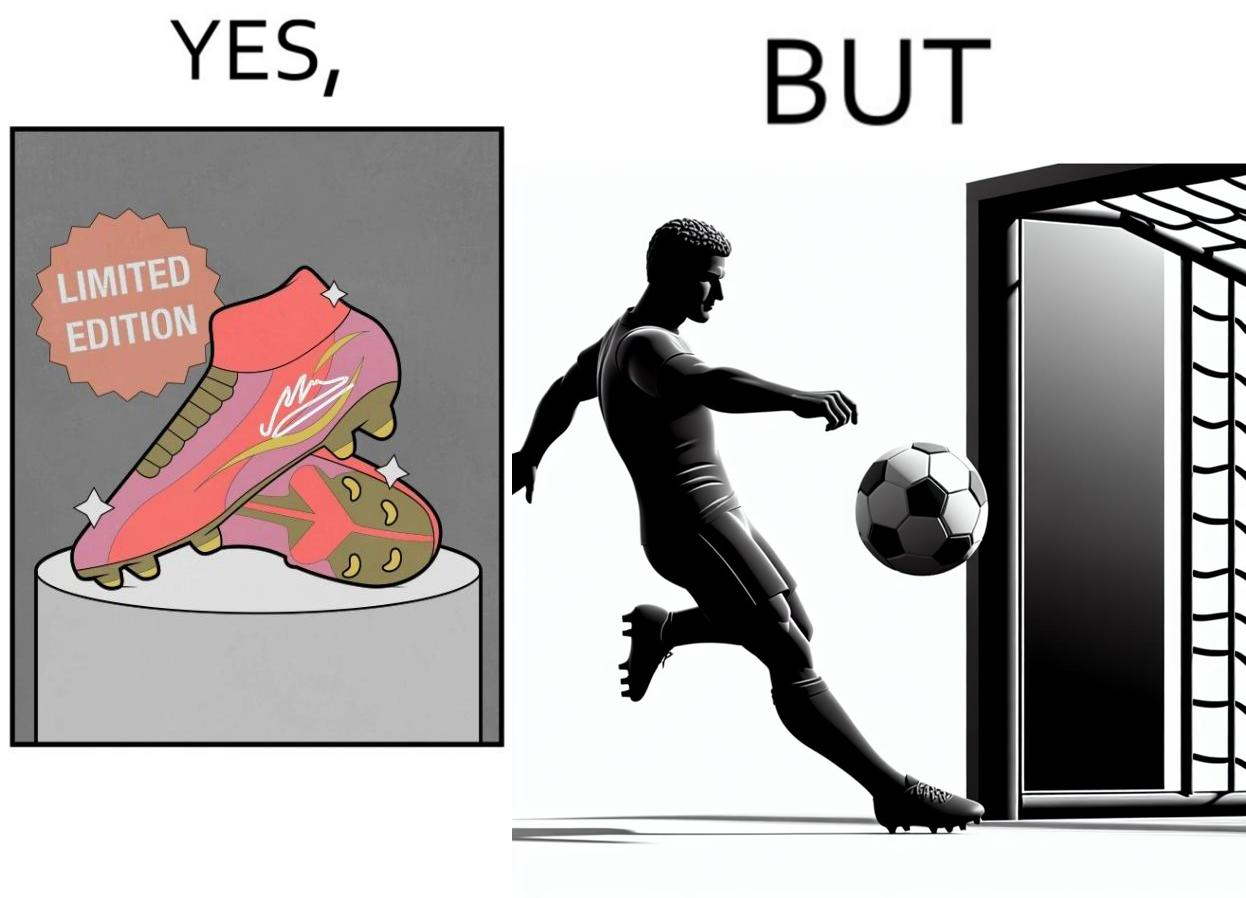What is shown in this image? The images are funny since they show how wearing expensive football boots does not make the user a better footballer. The footballer is still just as bad and it is a waste for him to buy such expensive boots 